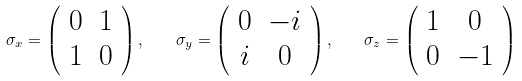Convert formula to latex. <formula><loc_0><loc_0><loc_500><loc_500>\sigma _ { x } = \left ( \begin{array} { c c } 0 & 1 \\ 1 & 0 \end{array} \right ) , \quad \sigma _ { y } = \left ( \begin{array} { c c } 0 & - i \\ i & 0 \end{array} \right ) , \quad \sigma _ { z } = \left ( \begin{array} { c c } 1 & 0 \\ 0 & - 1 \end{array} \right )</formula> 